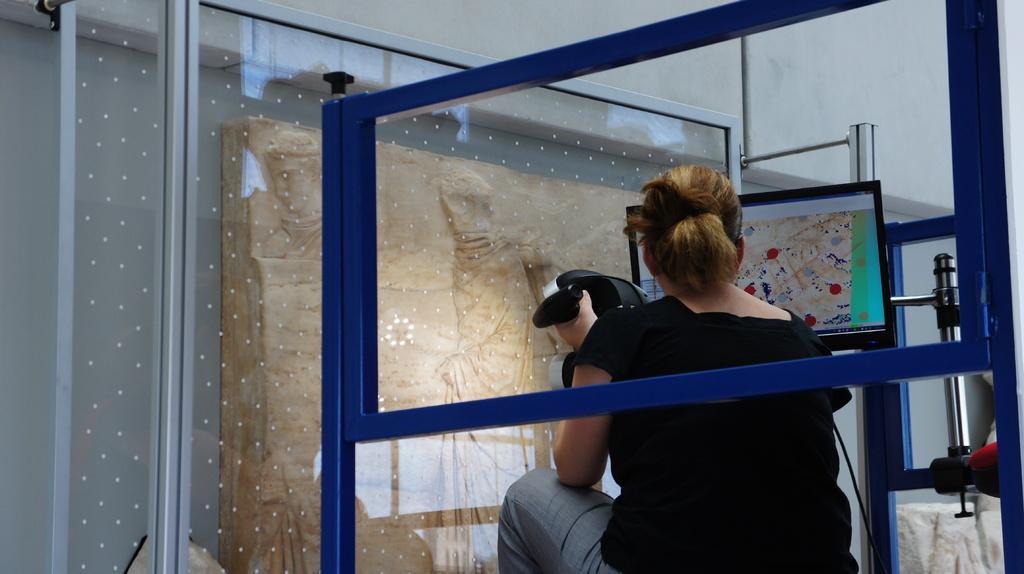Could you give a brief overview of what you see in this image? In this image we can see a woman sitting and holding an object, we can see a television and there is a blue color stand and glass, on the left side we can see some object. 